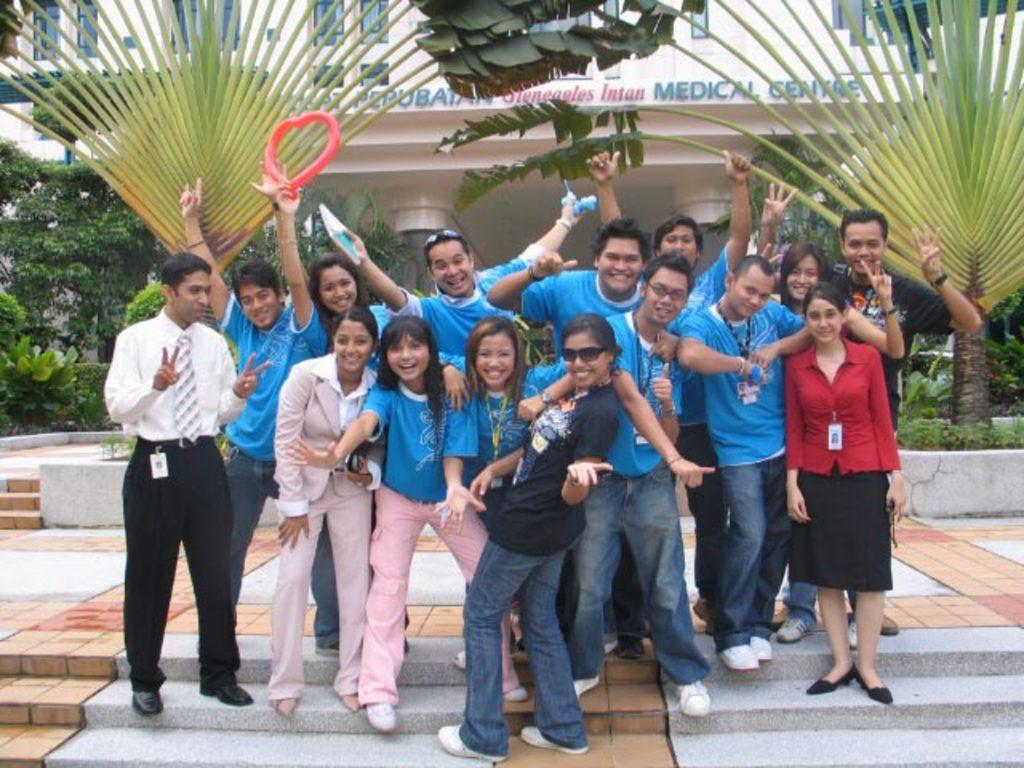What are the people in the image doing? The facts do not specify what the people are doing, but they are standing in the image. What architectural feature is present at the bottom of the image? There are stairs at the bottom of the image. What can be seen in the background of the image? There is a building and trees in the background of the image. What type of feather can be seen floating near the people in the image? There is no feather present in the image. Is there a volleyball game taking place in the image? The facts do not mention a volleyball game or any sports activity in the image. Can you see a flame coming from the building in the background? There is no mention of a flame or fire in the image. 